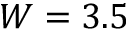Convert formula to latex. <formula><loc_0><loc_0><loc_500><loc_500>W = 3 . 5</formula> 